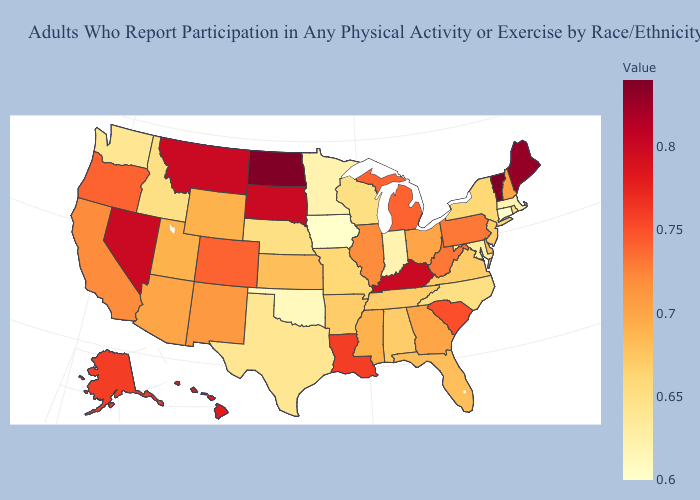Which states have the highest value in the USA?
Answer briefly. North Dakota, Vermont. Which states have the lowest value in the South?
Short answer required. Oklahoma. Among the states that border Missouri , which have the highest value?
Quick response, please. Kentucky. Does Indiana have a lower value than Arizona?
Answer briefly. Yes. Which states hav the highest value in the MidWest?
Write a very short answer. North Dakota. Which states have the lowest value in the USA?
Concise answer only. Connecticut, Iowa. Which states have the lowest value in the USA?
Write a very short answer. Connecticut, Iowa. Does Mississippi have the lowest value in the USA?
Write a very short answer. No. 